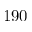<formula> <loc_0><loc_0><loc_500><loc_500>1 9 0</formula> 